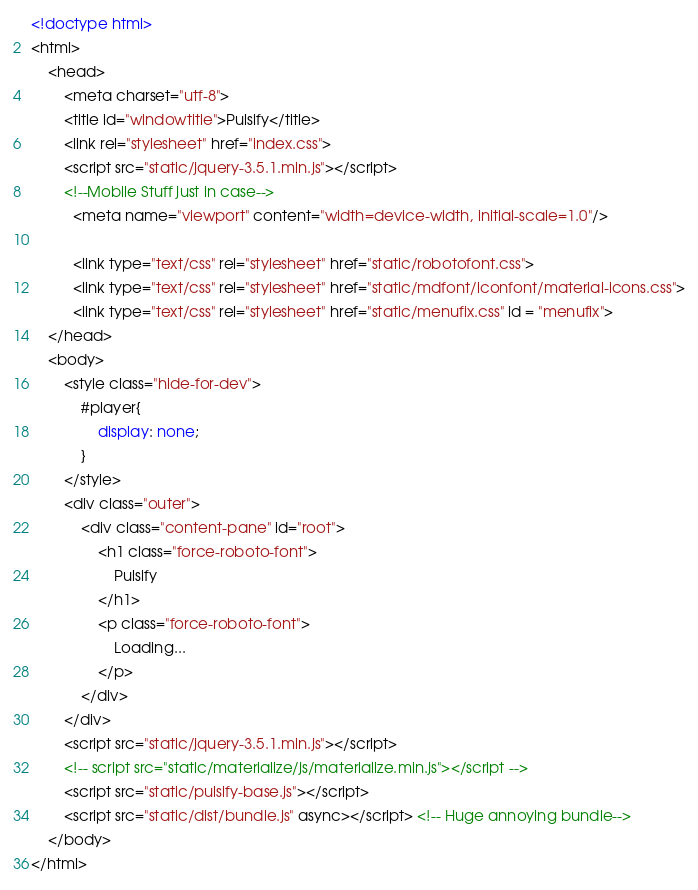Convert code to text. <code><loc_0><loc_0><loc_500><loc_500><_HTML_><!doctype html>
<html>
	<head>
		<meta charset="utf-8">
		<title id="windowtitle">Pulsify</title>
		<link rel="stylesheet" href="index.css">
		<script src="static/jquery-3.5.1.min.js"></script>
		<!--Mobile Stuff just in case-->
		  <meta name="viewport" content="width=device-width, initial-scale=1.0"/>

		  <link type="text/css" rel="stylesheet" href="static/robotofont.css">
		  <link type="text/css" rel="stylesheet" href="static/mdfont/iconfont/material-icons.css">
		  <link type="text/css" rel="stylesheet" href="static/menufix.css" id = "menufix">
	</head>
	<body>
		<style class="hide-for-dev">
			#player{
				display: none;
			}
		</style>
		<div class="outer">
			<div class="content-pane" id="root">
				<h1 class="force-roboto-font">
					Pulsify
				</h1>
				<p class="force-roboto-font">
					Loading...
				</p>
			</div>
		</div>
		<script src="static/jquery-3.5.1.min.js"></script>
		<!-- script src="static/materialize/js/materialize.min.js"></script -->
		<script src="static/pulsify-base.js"></script>
		<script src="static/dist/bundle.js" async></script> <!-- Huge annoying bundle-->
	</body>
</html>
</code> 